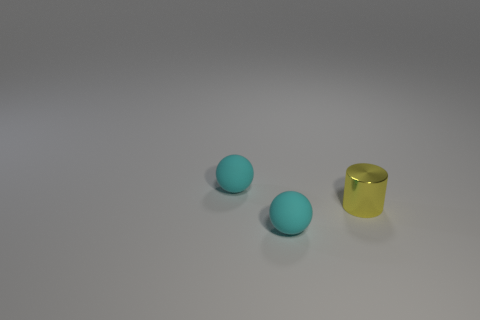Add 2 small blue metal things. How many objects exist? 5 Subtract all cylinders. How many objects are left? 2 Subtract all yellow metallic things. Subtract all tiny cyan rubber things. How many objects are left? 0 Add 3 tiny things. How many tiny things are left? 6 Add 2 green matte spheres. How many green matte spheres exist? 2 Subtract 0 brown balls. How many objects are left? 3 